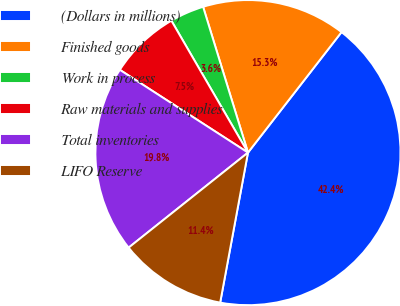Convert chart to OTSL. <chart><loc_0><loc_0><loc_500><loc_500><pie_chart><fcel>(Dollars in millions)<fcel>Finished goods<fcel>Work in process<fcel>Raw materials and supplies<fcel>Total inventories<fcel>LIFO Reserve<nl><fcel>42.41%<fcel>15.26%<fcel>3.62%<fcel>7.5%<fcel>19.83%<fcel>11.38%<nl></chart> 